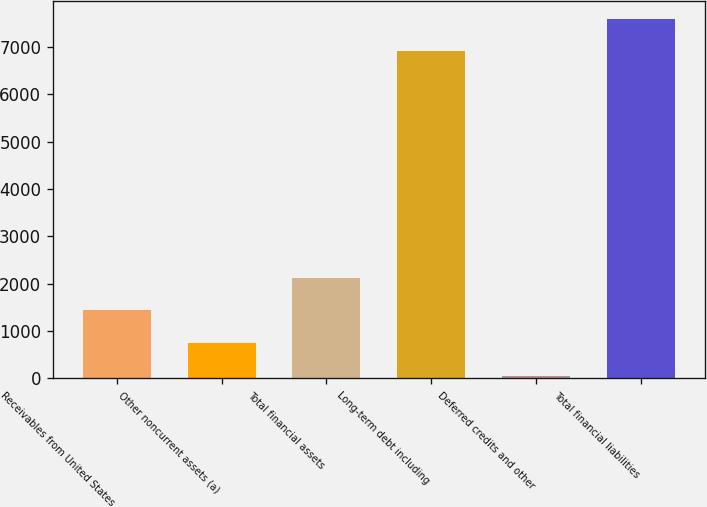Convert chart to OTSL. <chart><loc_0><loc_0><loc_500><loc_500><bar_chart><fcel>Receivables from United States<fcel>Other noncurrent assets (a)<fcel>Total financial assets<fcel>Long-term debt including<fcel>Deferred credits and other<fcel>Total financial liabilities<nl><fcel>1436.4<fcel>745.7<fcel>2127.1<fcel>6907<fcel>55<fcel>7597.7<nl></chart> 